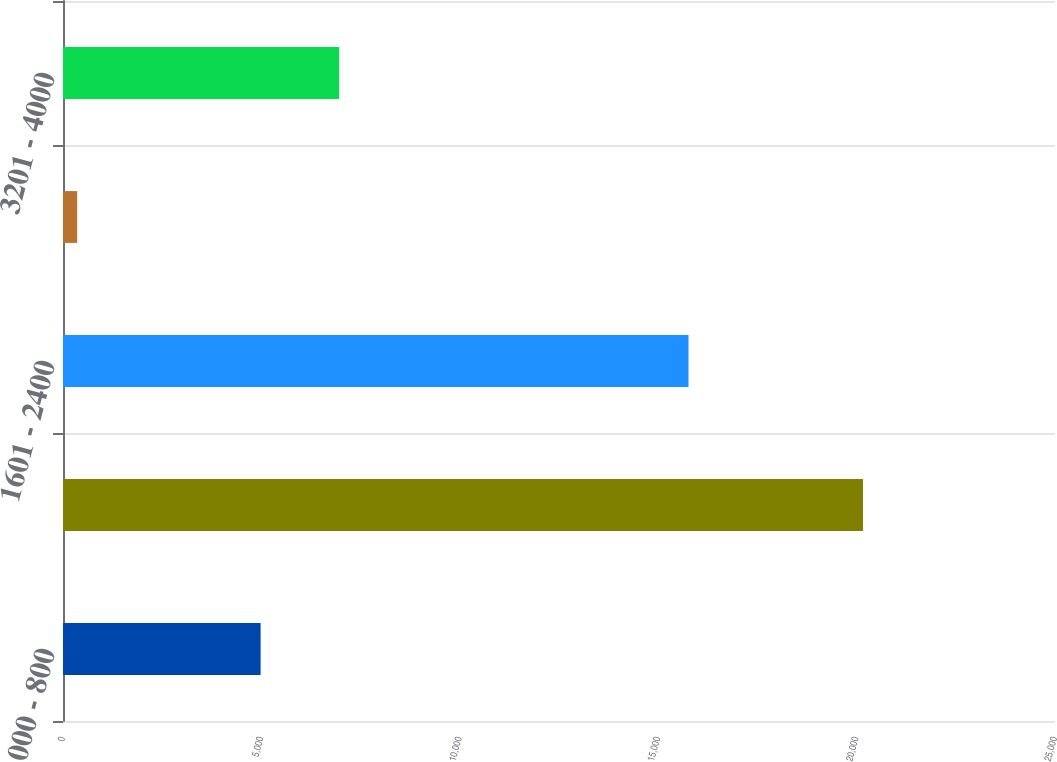Convert chart. <chart><loc_0><loc_0><loc_500><loc_500><bar_chart><fcel>000 - 800<fcel>801 - 1600<fcel>1601 - 2400<fcel>2401 - 3200<fcel>3201 - 4000<nl><fcel>4980<fcel>20161<fcel>15764<fcel>358<fcel>6960.3<nl></chart> 